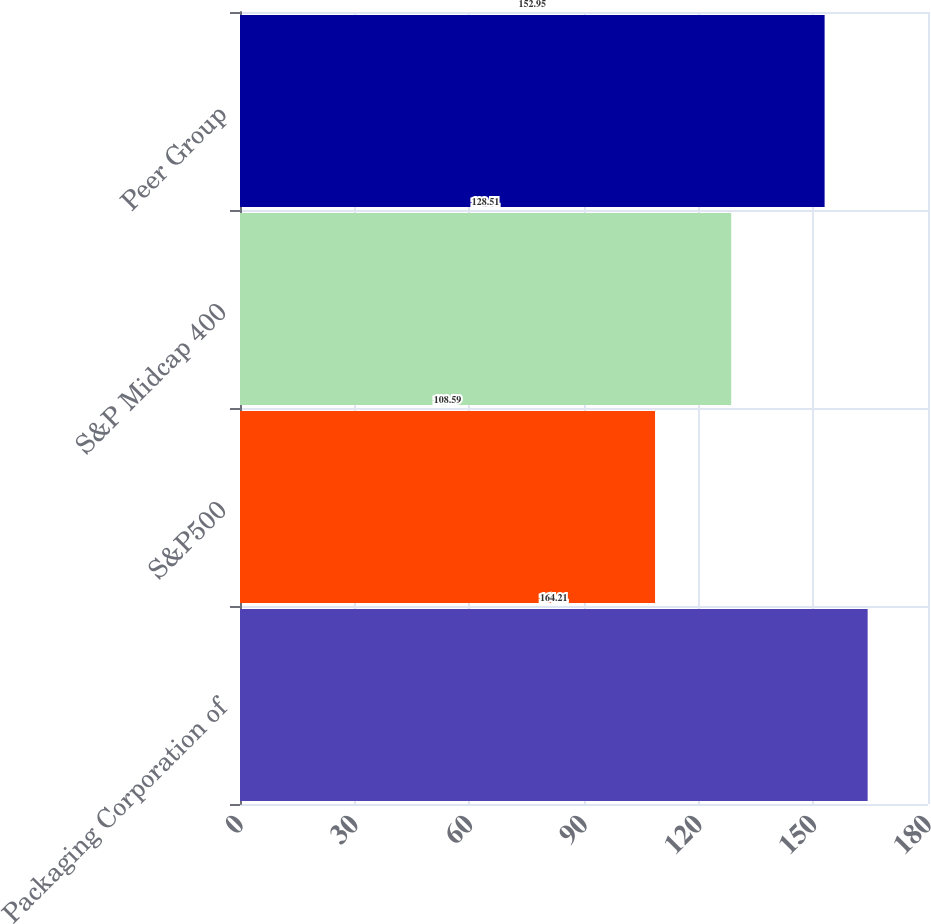Convert chart. <chart><loc_0><loc_0><loc_500><loc_500><bar_chart><fcel>Packaging Corporation of<fcel>S&P500<fcel>S&P Midcap 400<fcel>Peer Group<nl><fcel>164.21<fcel>108.59<fcel>128.51<fcel>152.95<nl></chart> 